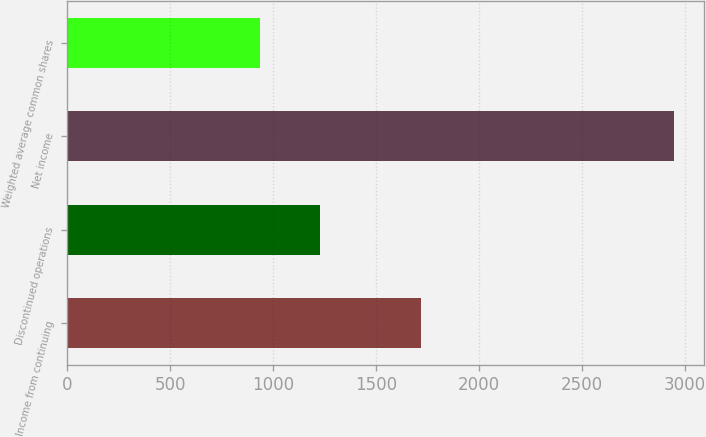<chart> <loc_0><loc_0><loc_500><loc_500><bar_chart><fcel>Income from continuing<fcel>Discontinued operations<fcel>Net income<fcel>Weighted average common shares<nl><fcel>1718<fcel>1228<fcel>2946<fcel>933.6<nl></chart> 